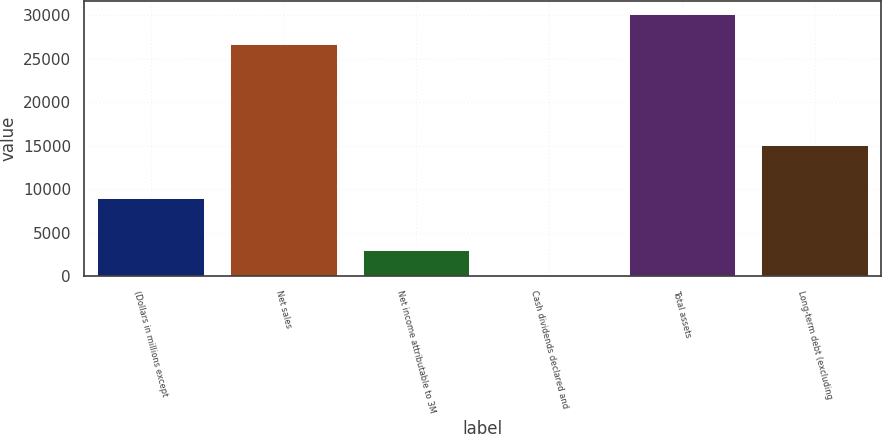Convert chart. <chart><loc_0><loc_0><loc_500><loc_500><bar_chart><fcel>(Dollars in millions except<fcel>Net sales<fcel>Net income attributable to 3M<fcel>Cash dividends declared and<fcel>Total assets<fcel>Long-term debt (excluding<nl><fcel>9048.27<fcel>26662<fcel>3017.49<fcel>2.1<fcel>30156<fcel>15079<nl></chart> 